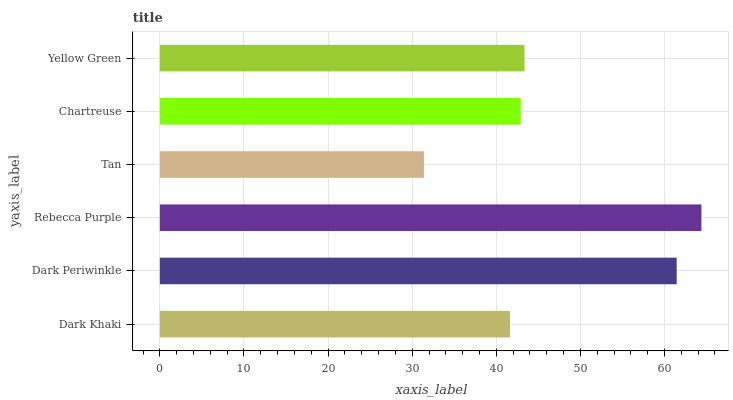Is Tan the minimum?
Answer yes or no. Yes. Is Rebecca Purple the maximum?
Answer yes or no. Yes. Is Dark Periwinkle the minimum?
Answer yes or no. No. Is Dark Periwinkle the maximum?
Answer yes or no. No. Is Dark Periwinkle greater than Dark Khaki?
Answer yes or no. Yes. Is Dark Khaki less than Dark Periwinkle?
Answer yes or no. Yes. Is Dark Khaki greater than Dark Periwinkle?
Answer yes or no. No. Is Dark Periwinkle less than Dark Khaki?
Answer yes or no. No. Is Yellow Green the high median?
Answer yes or no. Yes. Is Chartreuse the low median?
Answer yes or no. Yes. Is Chartreuse the high median?
Answer yes or no. No. Is Dark Khaki the low median?
Answer yes or no. No. 